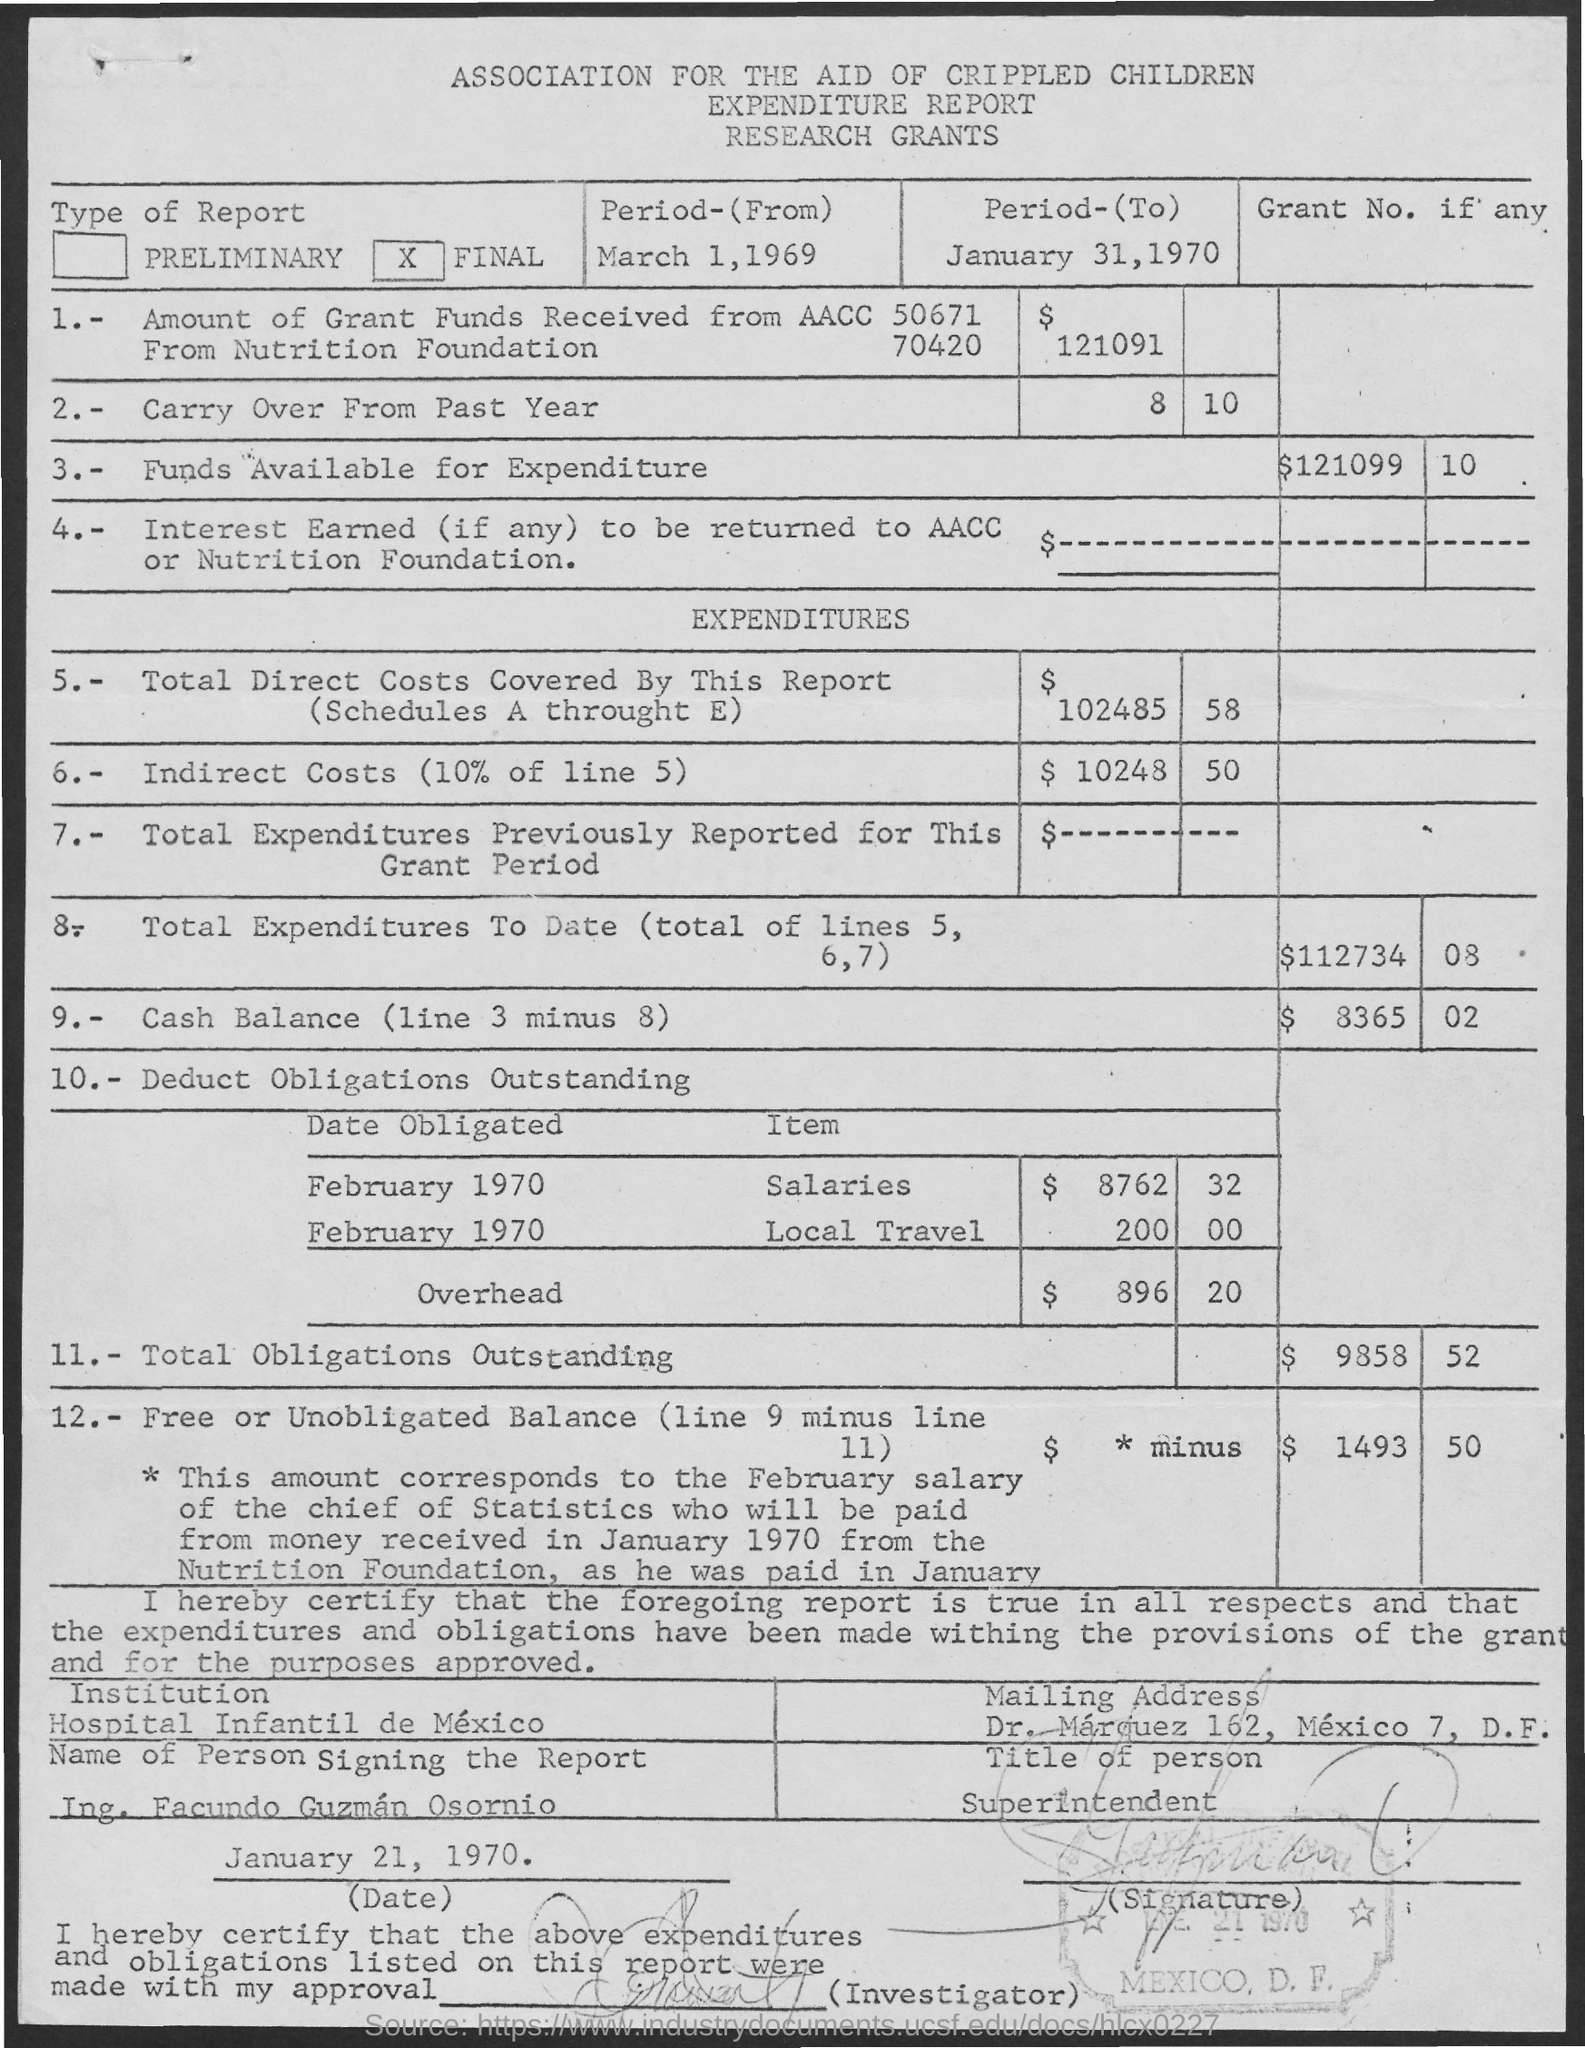What are the Funds available for expenditure?
Your response must be concise. $121099 10. What is the ToTAL Direct Costs covered by this report?
Offer a very short reply. 102485.58. What are the indirect costs?
Give a very brief answer. $10248.50. Which is the institution?
Offer a terse response. Hospital Infantil de Mexico. What is the Title of the Person?
Your response must be concise. Superintendent. 